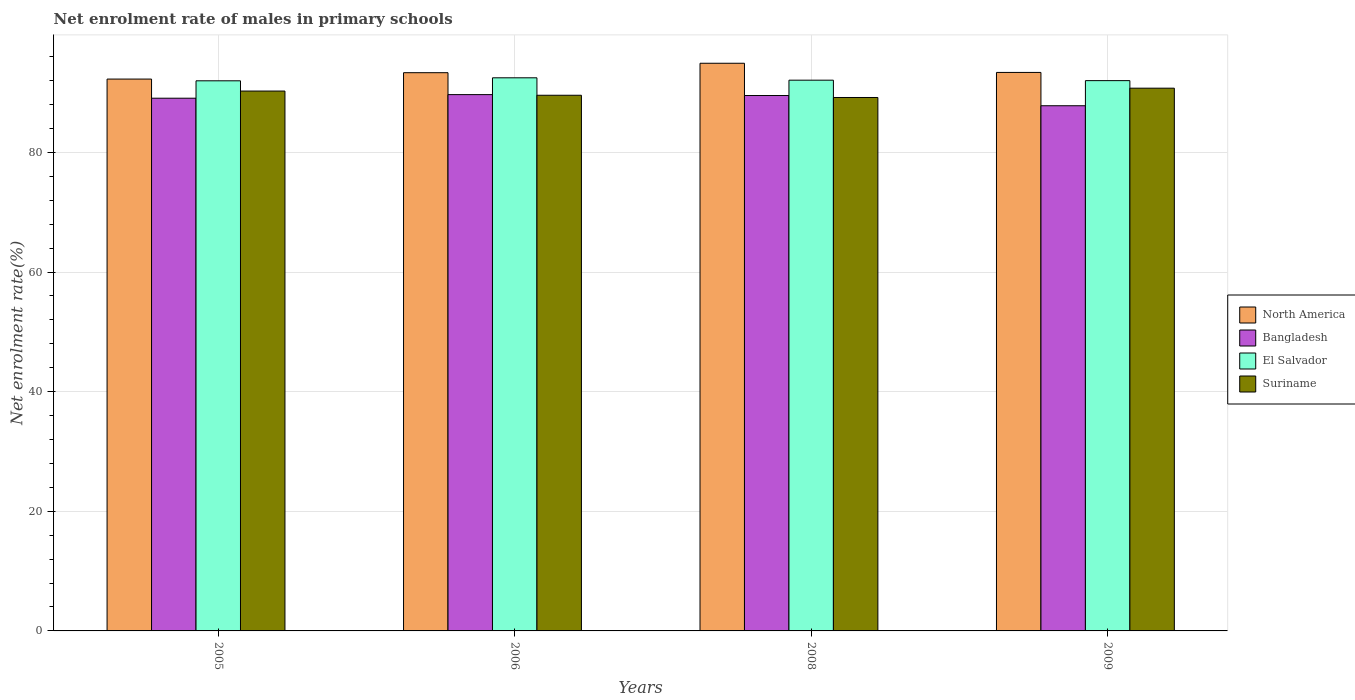How many different coloured bars are there?
Ensure brevity in your answer.  4. How many bars are there on the 3rd tick from the left?
Ensure brevity in your answer.  4. What is the label of the 3rd group of bars from the left?
Offer a very short reply. 2008. In how many cases, is the number of bars for a given year not equal to the number of legend labels?
Make the answer very short. 0. What is the net enrolment rate of males in primary schools in El Salvador in 2008?
Offer a very short reply. 92.07. Across all years, what is the maximum net enrolment rate of males in primary schools in North America?
Offer a terse response. 94.9. Across all years, what is the minimum net enrolment rate of males in primary schools in El Salvador?
Keep it short and to the point. 91.96. What is the total net enrolment rate of males in primary schools in Bangladesh in the graph?
Your answer should be compact. 356.01. What is the difference between the net enrolment rate of males in primary schools in Bangladesh in 2005 and that in 2006?
Give a very brief answer. -0.6. What is the difference between the net enrolment rate of males in primary schools in Suriname in 2005 and the net enrolment rate of males in primary schools in El Salvador in 2006?
Provide a short and direct response. -2.21. What is the average net enrolment rate of males in primary schools in Suriname per year?
Give a very brief answer. 89.92. In the year 2005, what is the difference between the net enrolment rate of males in primary schools in Bangladesh and net enrolment rate of males in primary schools in Suriname?
Offer a terse response. -1.19. What is the ratio of the net enrolment rate of males in primary schools in Suriname in 2005 to that in 2009?
Ensure brevity in your answer.  0.99. Is the net enrolment rate of males in primary schools in Suriname in 2005 less than that in 2006?
Make the answer very short. No. What is the difference between the highest and the second highest net enrolment rate of males in primary schools in El Salvador?
Offer a terse response. 0.4. What is the difference between the highest and the lowest net enrolment rate of males in primary schools in El Salvador?
Provide a short and direct response. 0.5. In how many years, is the net enrolment rate of males in primary schools in El Salvador greater than the average net enrolment rate of males in primary schools in El Salvador taken over all years?
Offer a terse response. 1. Is the sum of the net enrolment rate of males in primary schools in North America in 2006 and 2009 greater than the maximum net enrolment rate of males in primary schools in Bangladesh across all years?
Offer a terse response. Yes. Is it the case that in every year, the sum of the net enrolment rate of males in primary schools in Suriname and net enrolment rate of males in primary schools in El Salvador is greater than the sum of net enrolment rate of males in primary schools in Bangladesh and net enrolment rate of males in primary schools in North America?
Your response must be concise. Yes. What does the 2nd bar from the right in 2005 represents?
Offer a very short reply. El Salvador. How many years are there in the graph?
Make the answer very short. 4. What is the difference between two consecutive major ticks on the Y-axis?
Make the answer very short. 20. Are the values on the major ticks of Y-axis written in scientific E-notation?
Give a very brief answer. No. Does the graph contain grids?
Provide a succinct answer. Yes. How many legend labels are there?
Provide a short and direct response. 4. What is the title of the graph?
Provide a short and direct response. Net enrolment rate of males in primary schools. What is the label or title of the Y-axis?
Offer a very short reply. Net enrolment rate(%). What is the Net enrolment rate(%) of North America in 2005?
Your answer should be compact. 92.25. What is the Net enrolment rate(%) in Bangladesh in 2005?
Ensure brevity in your answer.  89.05. What is the Net enrolment rate(%) in El Salvador in 2005?
Ensure brevity in your answer.  91.96. What is the Net enrolment rate(%) in Suriname in 2005?
Ensure brevity in your answer.  90.25. What is the Net enrolment rate(%) of North America in 2006?
Keep it short and to the point. 93.32. What is the Net enrolment rate(%) in Bangladesh in 2006?
Provide a short and direct response. 89.65. What is the Net enrolment rate(%) of El Salvador in 2006?
Keep it short and to the point. 92.46. What is the Net enrolment rate(%) of Suriname in 2006?
Your answer should be compact. 89.55. What is the Net enrolment rate(%) in North America in 2008?
Offer a very short reply. 94.9. What is the Net enrolment rate(%) in Bangladesh in 2008?
Offer a terse response. 89.5. What is the Net enrolment rate(%) in El Salvador in 2008?
Offer a terse response. 92.07. What is the Net enrolment rate(%) in Suriname in 2008?
Make the answer very short. 89.17. What is the Net enrolment rate(%) of North America in 2009?
Ensure brevity in your answer.  93.36. What is the Net enrolment rate(%) of Bangladesh in 2009?
Provide a succinct answer. 87.79. What is the Net enrolment rate(%) in El Salvador in 2009?
Your response must be concise. 91.99. What is the Net enrolment rate(%) in Suriname in 2009?
Your response must be concise. 90.73. Across all years, what is the maximum Net enrolment rate(%) in North America?
Provide a short and direct response. 94.9. Across all years, what is the maximum Net enrolment rate(%) in Bangladesh?
Your answer should be compact. 89.65. Across all years, what is the maximum Net enrolment rate(%) of El Salvador?
Give a very brief answer. 92.46. Across all years, what is the maximum Net enrolment rate(%) of Suriname?
Provide a short and direct response. 90.73. Across all years, what is the minimum Net enrolment rate(%) of North America?
Your answer should be very brief. 92.25. Across all years, what is the minimum Net enrolment rate(%) of Bangladesh?
Make the answer very short. 87.79. Across all years, what is the minimum Net enrolment rate(%) in El Salvador?
Give a very brief answer. 91.96. Across all years, what is the minimum Net enrolment rate(%) in Suriname?
Provide a short and direct response. 89.17. What is the total Net enrolment rate(%) in North America in the graph?
Your response must be concise. 373.83. What is the total Net enrolment rate(%) in Bangladesh in the graph?
Your answer should be very brief. 356.01. What is the total Net enrolment rate(%) in El Salvador in the graph?
Offer a very short reply. 368.49. What is the total Net enrolment rate(%) of Suriname in the graph?
Provide a short and direct response. 359.7. What is the difference between the Net enrolment rate(%) in North America in 2005 and that in 2006?
Your answer should be compact. -1.07. What is the difference between the Net enrolment rate(%) of Bangladesh in 2005 and that in 2006?
Your answer should be compact. -0.6. What is the difference between the Net enrolment rate(%) in El Salvador in 2005 and that in 2006?
Give a very brief answer. -0.5. What is the difference between the Net enrolment rate(%) of Suriname in 2005 and that in 2006?
Offer a terse response. 0.7. What is the difference between the Net enrolment rate(%) in North America in 2005 and that in 2008?
Offer a very short reply. -2.64. What is the difference between the Net enrolment rate(%) of Bangladesh in 2005 and that in 2008?
Your answer should be very brief. -0.45. What is the difference between the Net enrolment rate(%) in El Salvador in 2005 and that in 2008?
Your answer should be very brief. -0.1. What is the difference between the Net enrolment rate(%) in Suriname in 2005 and that in 2008?
Your answer should be compact. 1.07. What is the difference between the Net enrolment rate(%) of North America in 2005 and that in 2009?
Your answer should be very brief. -1.11. What is the difference between the Net enrolment rate(%) of Bangladesh in 2005 and that in 2009?
Provide a short and direct response. 1.26. What is the difference between the Net enrolment rate(%) in El Salvador in 2005 and that in 2009?
Keep it short and to the point. -0.03. What is the difference between the Net enrolment rate(%) of Suriname in 2005 and that in 2009?
Make the answer very short. -0.48. What is the difference between the Net enrolment rate(%) in North America in 2006 and that in 2008?
Offer a very short reply. -1.58. What is the difference between the Net enrolment rate(%) in Bangladesh in 2006 and that in 2008?
Your response must be concise. 0.15. What is the difference between the Net enrolment rate(%) of El Salvador in 2006 and that in 2008?
Your answer should be compact. 0.4. What is the difference between the Net enrolment rate(%) of Suriname in 2006 and that in 2008?
Ensure brevity in your answer.  0.37. What is the difference between the Net enrolment rate(%) of North America in 2006 and that in 2009?
Provide a short and direct response. -0.04. What is the difference between the Net enrolment rate(%) of Bangladesh in 2006 and that in 2009?
Keep it short and to the point. 1.86. What is the difference between the Net enrolment rate(%) in El Salvador in 2006 and that in 2009?
Offer a terse response. 0.47. What is the difference between the Net enrolment rate(%) of Suriname in 2006 and that in 2009?
Keep it short and to the point. -1.18. What is the difference between the Net enrolment rate(%) in North America in 2008 and that in 2009?
Offer a terse response. 1.53. What is the difference between the Net enrolment rate(%) of Bangladesh in 2008 and that in 2009?
Your answer should be very brief. 1.71. What is the difference between the Net enrolment rate(%) in El Salvador in 2008 and that in 2009?
Provide a succinct answer. 0.07. What is the difference between the Net enrolment rate(%) of Suriname in 2008 and that in 2009?
Make the answer very short. -1.56. What is the difference between the Net enrolment rate(%) in North America in 2005 and the Net enrolment rate(%) in Bangladesh in 2006?
Provide a succinct answer. 2.6. What is the difference between the Net enrolment rate(%) of North America in 2005 and the Net enrolment rate(%) of El Salvador in 2006?
Your answer should be compact. -0.21. What is the difference between the Net enrolment rate(%) in North America in 2005 and the Net enrolment rate(%) in Suriname in 2006?
Your response must be concise. 2.71. What is the difference between the Net enrolment rate(%) in Bangladesh in 2005 and the Net enrolment rate(%) in El Salvador in 2006?
Offer a very short reply. -3.41. What is the difference between the Net enrolment rate(%) in Bangladesh in 2005 and the Net enrolment rate(%) in Suriname in 2006?
Ensure brevity in your answer.  -0.49. What is the difference between the Net enrolment rate(%) in El Salvador in 2005 and the Net enrolment rate(%) in Suriname in 2006?
Your answer should be very brief. 2.42. What is the difference between the Net enrolment rate(%) of North America in 2005 and the Net enrolment rate(%) of Bangladesh in 2008?
Your answer should be very brief. 2.75. What is the difference between the Net enrolment rate(%) in North America in 2005 and the Net enrolment rate(%) in El Salvador in 2008?
Your response must be concise. 0.19. What is the difference between the Net enrolment rate(%) of North America in 2005 and the Net enrolment rate(%) of Suriname in 2008?
Ensure brevity in your answer.  3.08. What is the difference between the Net enrolment rate(%) in Bangladesh in 2005 and the Net enrolment rate(%) in El Salvador in 2008?
Your answer should be very brief. -3.01. What is the difference between the Net enrolment rate(%) in Bangladesh in 2005 and the Net enrolment rate(%) in Suriname in 2008?
Provide a succinct answer. -0.12. What is the difference between the Net enrolment rate(%) in El Salvador in 2005 and the Net enrolment rate(%) in Suriname in 2008?
Ensure brevity in your answer.  2.79. What is the difference between the Net enrolment rate(%) in North America in 2005 and the Net enrolment rate(%) in Bangladesh in 2009?
Keep it short and to the point. 4.46. What is the difference between the Net enrolment rate(%) in North America in 2005 and the Net enrolment rate(%) in El Salvador in 2009?
Offer a terse response. 0.26. What is the difference between the Net enrolment rate(%) in North America in 2005 and the Net enrolment rate(%) in Suriname in 2009?
Your answer should be very brief. 1.52. What is the difference between the Net enrolment rate(%) of Bangladesh in 2005 and the Net enrolment rate(%) of El Salvador in 2009?
Make the answer very short. -2.94. What is the difference between the Net enrolment rate(%) of Bangladesh in 2005 and the Net enrolment rate(%) of Suriname in 2009?
Ensure brevity in your answer.  -1.68. What is the difference between the Net enrolment rate(%) in El Salvador in 2005 and the Net enrolment rate(%) in Suriname in 2009?
Your response must be concise. 1.23. What is the difference between the Net enrolment rate(%) of North America in 2006 and the Net enrolment rate(%) of Bangladesh in 2008?
Your answer should be compact. 3.82. What is the difference between the Net enrolment rate(%) of North America in 2006 and the Net enrolment rate(%) of El Salvador in 2008?
Ensure brevity in your answer.  1.25. What is the difference between the Net enrolment rate(%) in North America in 2006 and the Net enrolment rate(%) in Suriname in 2008?
Provide a short and direct response. 4.15. What is the difference between the Net enrolment rate(%) in Bangladesh in 2006 and the Net enrolment rate(%) in El Salvador in 2008?
Provide a short and direct response. -2.41. What is the difference between the Net enrolment rate(%) of Bangladesh in 2006 and the Net enrolment rate(%) of Suriname in 2008?
Offer a terse response. 0.48. What is the difference between the Net enrolment rate(%) in El Salvador in 2006 and the Net enrolment rate(%) in Suriname in 2008?
Your answer should be compact. 3.29. What is the difference between the Net enrolment rate(%) in North America in 2006 and the Net enrolment rate(%) in Bangladesh in 2009?
Provide a short and direct response. 5.53. What is the difference between the Net enrolment rate(%) of North America in 2006 and the Net enrolment rate(%) of El Salvador in 2009?
Offer a very short reply. 1.33. What is the difference between the Net enrolment rate(%) of North America in 2006 and the Net enrolment rate(%) of Suriname in 2009?
Offer a very short reply. 2.59. What is the difference between the Net enrolment rate(%) of Bangladesh in 2006 and the Net enrolment rate(%) of El Salvador in 2009?
Make the answer very short. -2.34. What is the difference between the Net enrolment rate(%) in Bangladesh in 2006 and the Net enrolment rate(%) in Suriname in 2009?
Your response must be concise. -1.08. What is the difference between the Net enrolment rate(%) of El Salvador in 2006 and the Net enrolment rate(%) of Suriname in 2009?
Ensure brevity in your answer.  1.73. What is the difference between the Net enrolment rate(%) of North America in 2008 and the Net enrolment rate(%) of Bangladesh in 2009?
Keep it short and to the point. 7.1. What is the difference between the Net enrolment rate(%) in North America in 2008 and the Net enrolment rate(%) in El Salvador in 2009?
Ensure brevity in your answer.  2.9. What is the difference between the Net enrolment rate(%) in North America in 2008 and the Net enrolment rate(%) in Suriname in 2009?
Provide a short and direct response. 4.17. What is the difference between the Net enrolment rate(%) in Bangladesh in 2008 and the Net enrolment rate(%) in El Salvador in 2009?
Provide a succinct answer. -2.49. What is the difference between the Net enrolment rate(%) in Bangladesh in 2008 and the Net enrolment rate(%) in Suriname in 2009?
Offer a very short reply. -1.23. What is the difference between the Net enrolment rate(%) in El Salvador in 2008 and the Net enrolment rate(%) in Suriname in 2009?
Your answer should be very brief. 1.34. What is the average Net enrolment rate(%) in North America per year?
Give a very brief answer. 93.46. What is the average Net enrolment rate(%) in Bangladesh per year?
Keep it short and to the point. 89. What is the average Net enrolment rate(%) in El Salvador per year?
Make the answer very short. 92.12. What is the average Net enrolment rate(%) in Suriname per year?
Offer a very short reply. 89.92. In the year 2005, what is the difference between the Net enrolment rate(%) in North America and Net enrolment rate(%) in Bangladesh?
Offer a very short reply. 3.2. In the year 2005, what is the difference between the Net enrolment rate(%) in North America and Net enrolment rate(%) in El Salvador?
Your response must be concise. 0.29. In the year 2005, what is the difference between the Net enrolment rate(%) in North America and Net enrolment rate(%) in Suriname?
Ensure brevity in your answer.  2. In the year 2005, what is the difference between the Net enrolment rate(%) in Bangladesh and Net enrolment rate(%) in El Salvador?
Your answer should be very brief. -2.91. In the year 2005, what is the difference between the Net enrolment rate(%) of Bangladesh and Net enrolment rate(%) of Suriname?
Offer a very short reply. -1.19. In the year 2005, what is the difference between the Net enrolment rate(%) of El Salvador and Net enrolment rate(%) of Suriname?
Keep it short and to the point. 1.71. In the year 2006, what is the difference between the Net enrolment rate(%) of North America and Net enrolment rate(%) of Bangladesh?
Provide a short and direct response. 3.67. In the year 2006, what is the difference between the Net enrolment rate(%) in North America and Net enrolment rate(%) in El Salvador?
Your response must be concise. 0.86. In the year 2006, what is the difference between the Net enrolment rate(%) of North America and Net enrolment rate(%) of Suriname?
Give a very brief answer. 3.77. In the year 2006, what is the difference between the Net enrolment rate(%) of Bangladesh and Net enrolment rate(%) of El Salvador?
Give a very brief answer. -2.81. In the year 2006, what is the difference between the Net enrolment rate(%) of Bangladesh and Net enrolment rate(%) of Suriname?
Your response must be concise. 0.11. In the year 2006, what is the difference between the Net enrolment rate(%) of El Salvador and Net enrolment rate(%) of Suriname?
Keep it short and to the point. 2.92. In the year 2008, what is the difference between the Net enrolment rate(%) in North America and Net enrolment rate(%) in Bangladesh?
Keep it short and to the point. 5.39. In the year 2008, what is the difference between the Net enrolment rate(%) in North America and Net enrolment rate(%) in El Salvador?
Provide a short and direct response. 2.83. In the year 2008, what is the difference between the Net enrolment rate(%) in North America and Net enrolment rate(%) in Suriname?
Your response must be concise. 5.72. In the year 2008, what is the difference between the Net enrolment rate(%) in Bangladesh and Net enrolment rate(%) in El Salvador?
Your response must be concise. -2.56. In the year 2008, what is the difference between the Net enrolment rate(%) in Bangladesh and Net enrolment rate(%) in Suriname?
Your answer should be compact. 0.33. In the year 2008, what is the difference between the Net enrolment rate(%) of El Salvador and Net enrolment rate(%) of Suriname?
Provide a succinct answer. 2.89. In the year 2009, what is the difference between the Net enrolment rate(%) in North America and Net enrolment rate(%) in Bangladesh?
Provide a short and direct response. 5.57. In the year 2009, what is the difference between the Net enrolment rate(%) of North America and Net enrolment rate(%) of El Salvador?
Offer a very short reply. 1.37. In the year 2009, what is the difference between the Net enrolment rate(%) of North America and Net enrolment rate(%) of Suriname?
Your answer should be compact. 2.63. In the year 2009, what is the difference between the Net enrolment rate(%) of Bangladesh and Net enrolment rate(%) of El Salvador?
Offer a terse response. -4.2. In the year 2009, what is the difference between the Net enrolment rate(%) in Bangladesh and Net enrolment rate(%) in Suriname?
Your response must be concise. -2.94. In the year 2009, what is the difference between the Net enrolment rate(%) of El Salvador and Net enrolment rate(%) of Suriname?
Ensure brevity in your answer.  1.26. What is the ratio of the Net enrolment rate(%) in Bangladesh in 2005 to that in 2006?
Make the answer very short. 0.99. What is the ratio of the Net enrolment rate(%) in El Salvador in 2005 to that in 2006?
Offer a very short reply. 0.99. What is the ratio of the Net enrolment rate(%) of Suriname in 2005 to that in 2006?
Provide a short and direct response. 1.01. What is the ratio of the Net enrolment rate(%) of North America in 2005 to that in 2008?
Your answer should be very brief. 0.97. What is the ratio of the Net enrolment rate(%) in Bangladesh in 2005 to that in 2008?
Your answer should be very brief. 0.99. What is the ratio of the Net enrolment rate(%) in Suriname in 2005 to that in 2008?
Offer a terse response. 1.01. What is the ratio of the Net enrolment rate(%) of North America in 2005 to that in 2009?
Provide a succinct answer. 0.99. What is the ratio of the Net enrolment rate(%) in Bangladesh in 2005 to that in 2009?
Your response must be concise. 1.01. What is the ratio of the Net enrolment rate(%) of Suriname in 2005 to that in 2009?
Ensure brevity in your answer.  0.99. What is the ratio of the Net enrolment rate(%) of North America in 2006 to that in 2008?
Ensure brevity in your answer.  0.98. What is the ratio of the Net enrolment rate(%) in North America in 2006 to that in 2009?
Your response must be concise. 1. What is the ratio of the Net enrolment rate(%) of Bangladesh in 2006 to that in 2009?
Your response must be concise. 1.02. What is the ratio of the Net enrolment rate(%) of El Salvador in 2006 to that in 2009?
Your answer should be compact. 1.01. What is the ratio of the Net enrolment rate(%) of Suriname in 2006 to that in 2009?
Offer a very short reply. 0.99. What is the ratio of the Net enrolment rate(%) of North America in 2008 to that in 2009?
Provide a succinct answer. 1.02. What is the ratio of the Net enrolment rate(%) of Bangladesh in 2008 to that in 2009?
Give a very brief answer. 1.02. What is the ratio of the Net enrolment rate(%) in Suriname in 2008 to that in 2009?
Give a very brief answer. 0.98. What is the difference between the highest and the second highest Net enrolment rate(%) in North America?
Offer a very short reply. 1.53. What is the difference between the highest and the second highest Net enrolment rate(%) of Bangladesh?
Your answer should be very brief. 0.15. What is the difference between the highest and the second highest Net enrolment rate(%) of El Salvador?
Offer a very short reply. 0.4. What is the difference between the highest and the second highest Net enrolment rate(%) of Suriname?
Provide a succinct answer. 0.48. What is the difference between the highest and the lowest Net enrolment rate(%) in North America?
Keep it short and to the point. 2.64. What is the difference between the highest and the lowest Net enrolment rate(%) of Bangladesh?
Provide a short and direct response. 1.86. What is the difference between the highest and the lowest Net enrolment rate(%) in El Salvador?
Your answer should be very brief. 0.5. What is the difference between the highest and the lowest Net enrolment rate(%) in Suriname?
Your answer should be very brief. 1.56. 